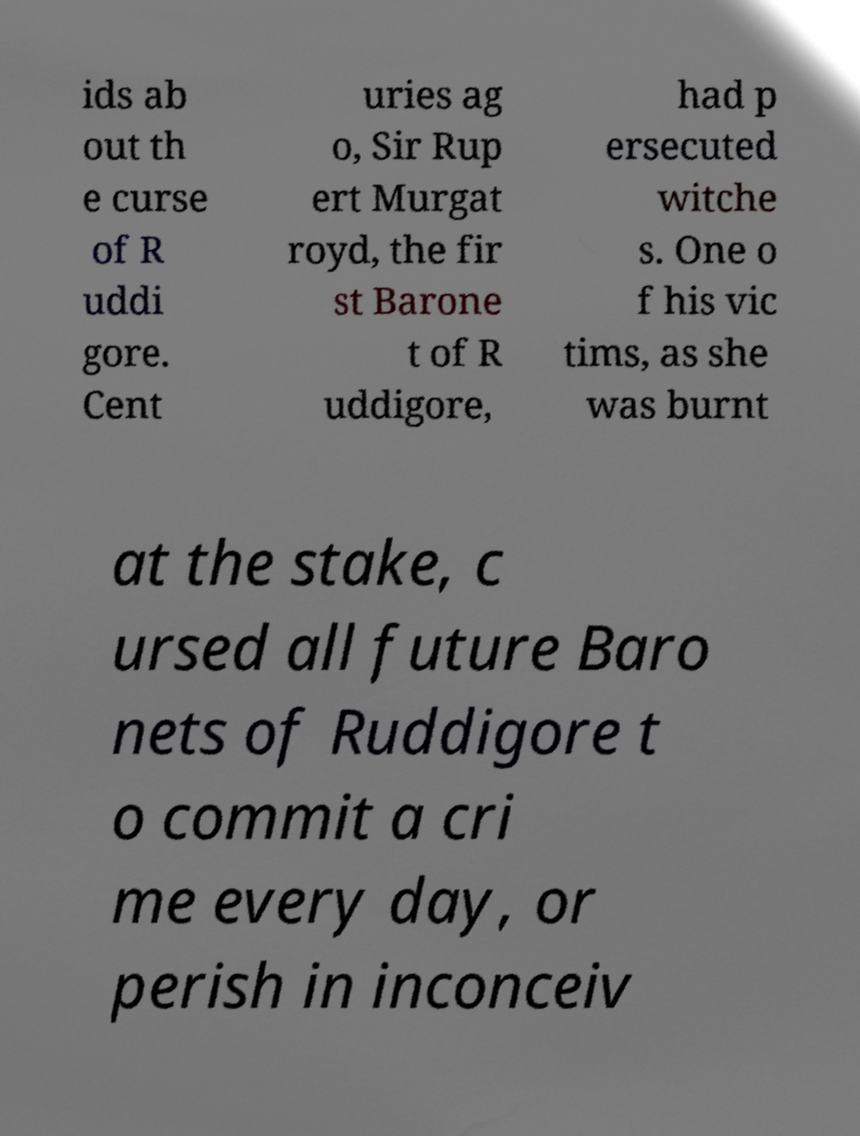Please identify and transcribe the text found in this image. ids ab out th e curse of R uddi gore. Cent uries ag o, Sir Rup ert Murgat royd, the fir st Barone t of R uddigore, had p ersecuted witche s. One o f his vic tims, as she was burnt at the stake, c ursed all future Baro nets of Ruddigore t o commit a cri me every day, or perish in inconceiv 